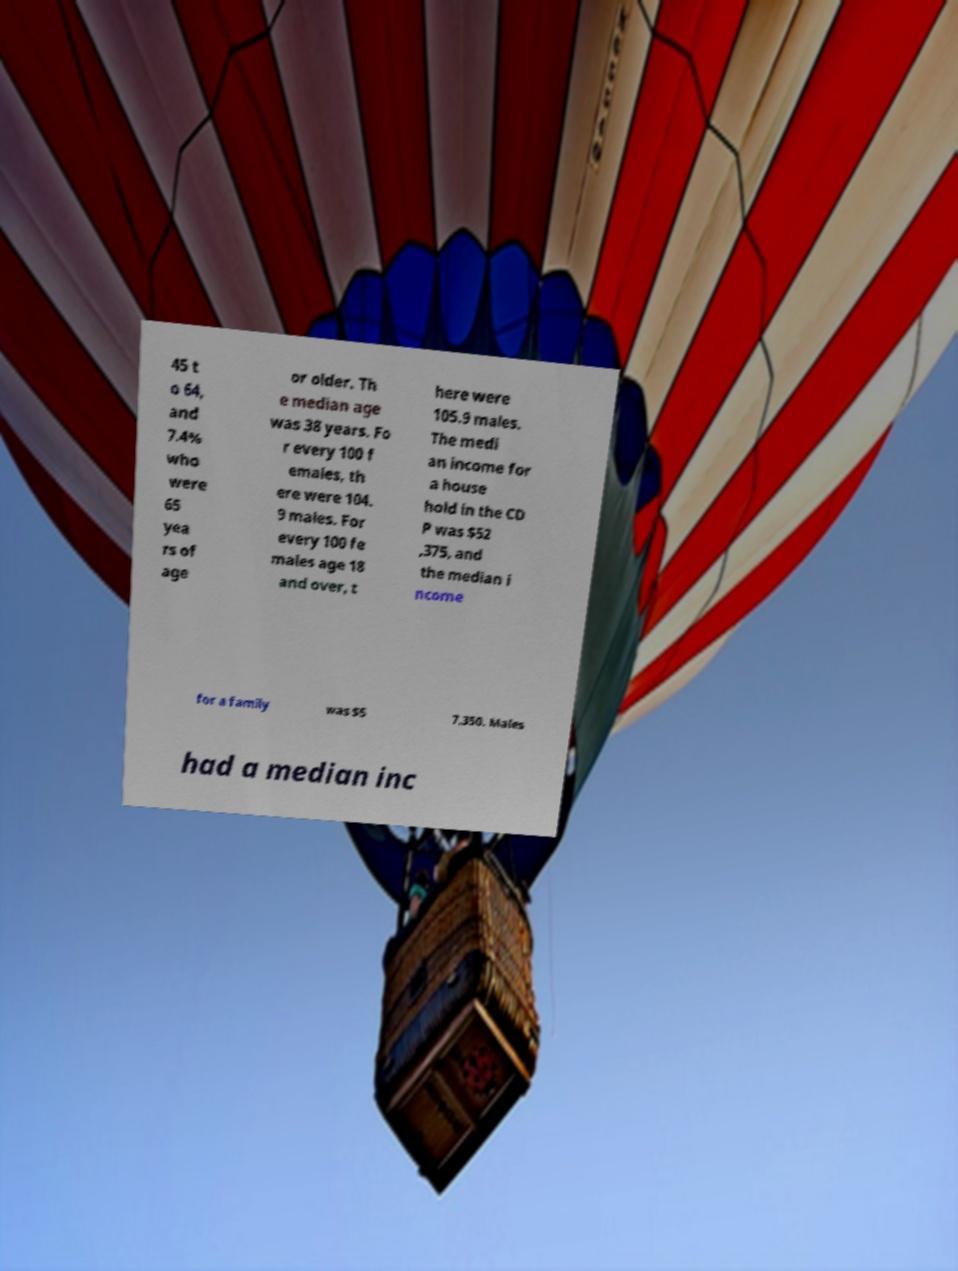I need the written content from this picture converted into text. Can you do that? 45 t o 64, and 7.4% who were 65 yea rs of age or older. Th e median age was 38 years. Fo r every 100 f emales, th ere were 104. 9 males. For every 100 fe males age 18 and over, t here were 105.9 males. The medi an income for a house hold in the CD P was $52 ,375, and the median i ncome for a family was $5 7,350. Males had a median inc 